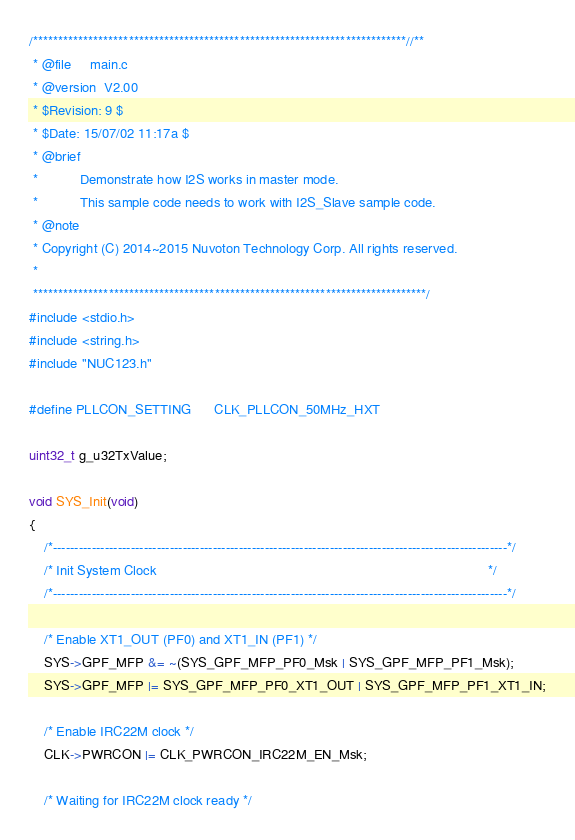Convert code to text. <code><loc_0><loc_0><loc_500><loc_500><_C_>/**************************************************************************//**
 * @file     main.c
 * @version  V2.00
 * $Revision: 9 $
 * $Date: 15/07/02 11:17a $
 * @brief
 *           Demonstrate how I2S works in master mode.
 *           This sample code needs to work with I2S_Slave sample code.
 * @note
 * Copyright (C) 2014~2015 Nuvoton Technology Corp. All rights reserved.
 *
 ******************************************************************************/
#include <stdio.h>
#include <string.h>
#include "NUC123.h"

#define PLLCON_SETTING      CLK_PLLCON_50MHz_HXT

uint32_t g_u32TxValue;

void SYS_Init(void)
{
    /*---------------------------------------------------------------------------------------------------------*/
    /* Init System Clock                                                                                       */
    /*---------------------------------------------------------------------------------------------------------*/

    /* Enable XT1_OUT (PF0) and XT1_IN (PF1) */
    SYS->GPF_MFP &= ~(SYS_GPF_MFP_PF0_Msk | SYS_GPF_MFP_PF1_Msk);
    SYS->GPF_MFP |= SYS_GPF_MFP_PF0_XT1_OUT | SYS_GPF_MFP_PF1_XT1_IN;

    /* Enable IRC22M clock */
    CLK->PWRCON |= CLK_PWRCON_IRC22M_EN_Msk;

    /* Waiting for IRC22M clock ready */</code> 